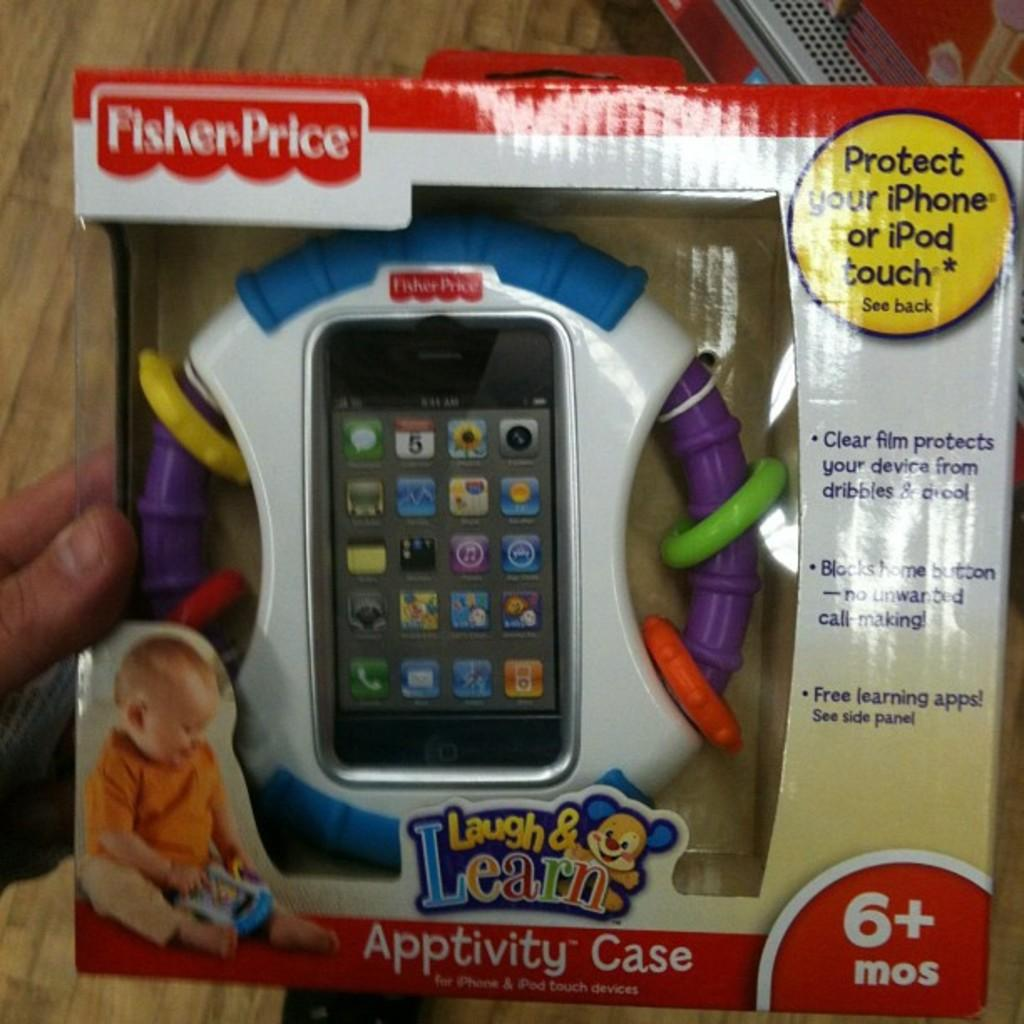<image>
Present a compact description of the photo's key features. An electronic device marketed towards babies by Fisher Price. 